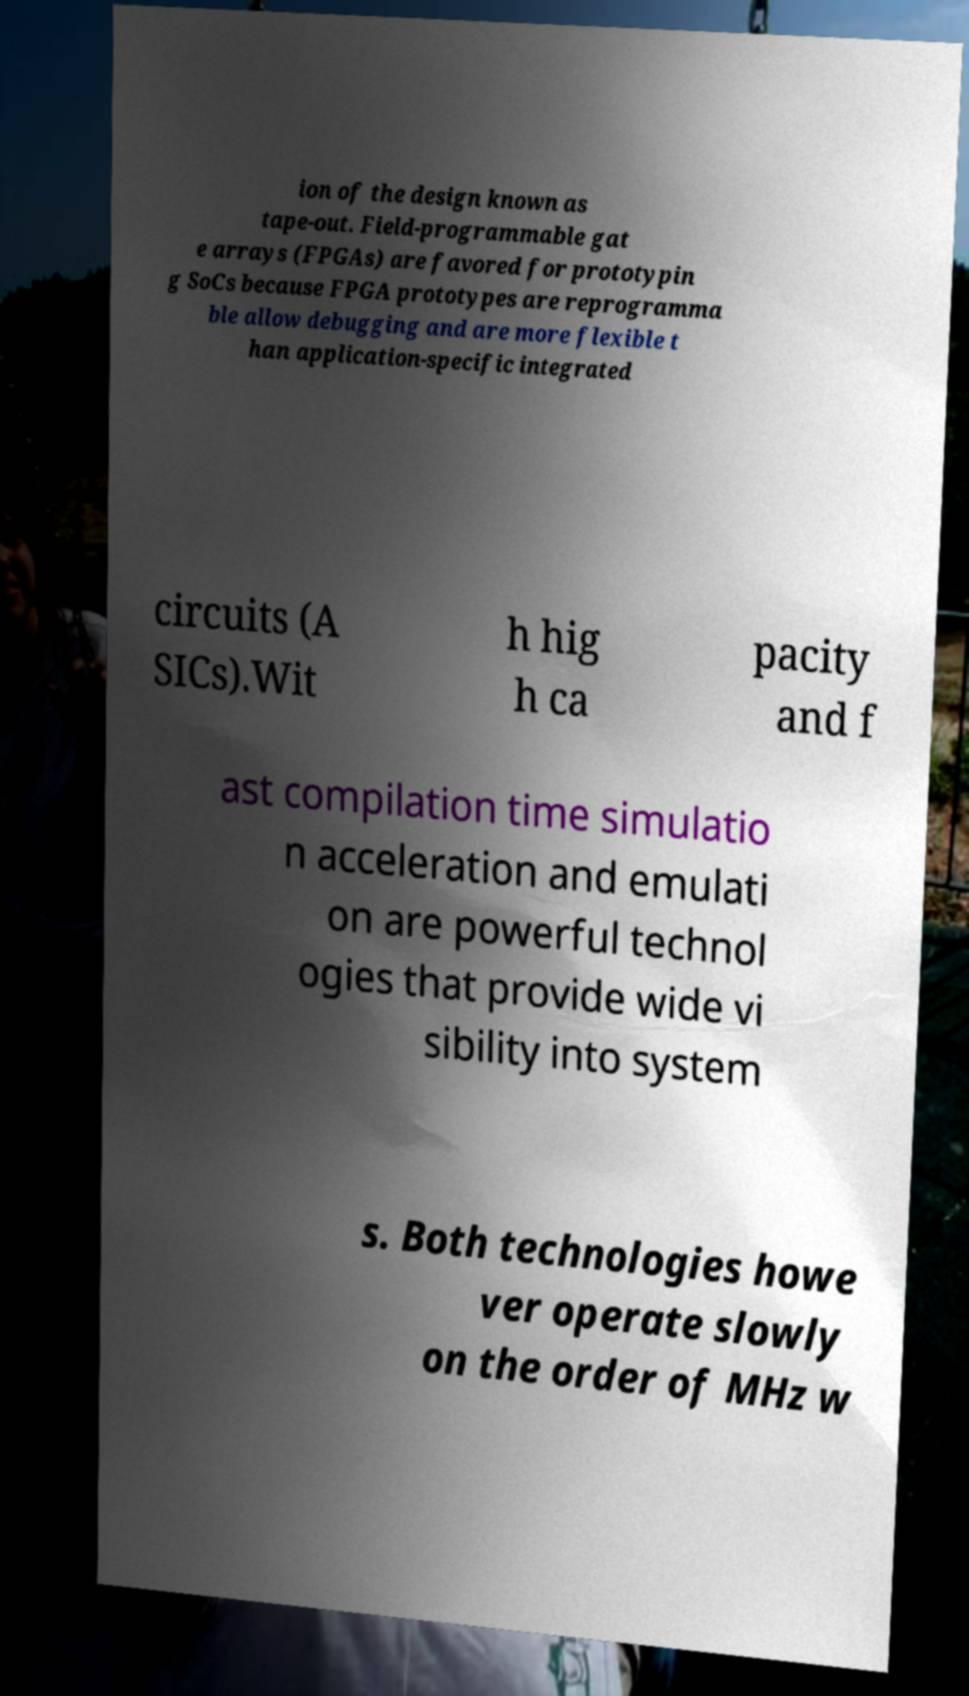Please read and relay the text visible in this image. What does it say? ion of the design known as tape-out. Field-programmable gat e arrays (FPGAs) are favored for prototypin g SoCs because FPGA prototypes are reprogramma ble allow debugging and are more flexible t han application-specific integrated circuits (A SICs).Wit h hig h ca pacity and f ast compilation time simulatio n acceleration and emulati on are powerful technol ogies that provide wide vi sibility into system s. Both technologies howe ver operate slowly on the order of MHz w 